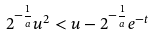Convert formula to latex. <formula><loc_0><loc_0><loc_500><loc_500>2 ^ { - \frac { 1 } { a } } u ^ { 2 } < u - 2 ^ { - \frac { 1 } { a } } e ^ { - t }</formula> 